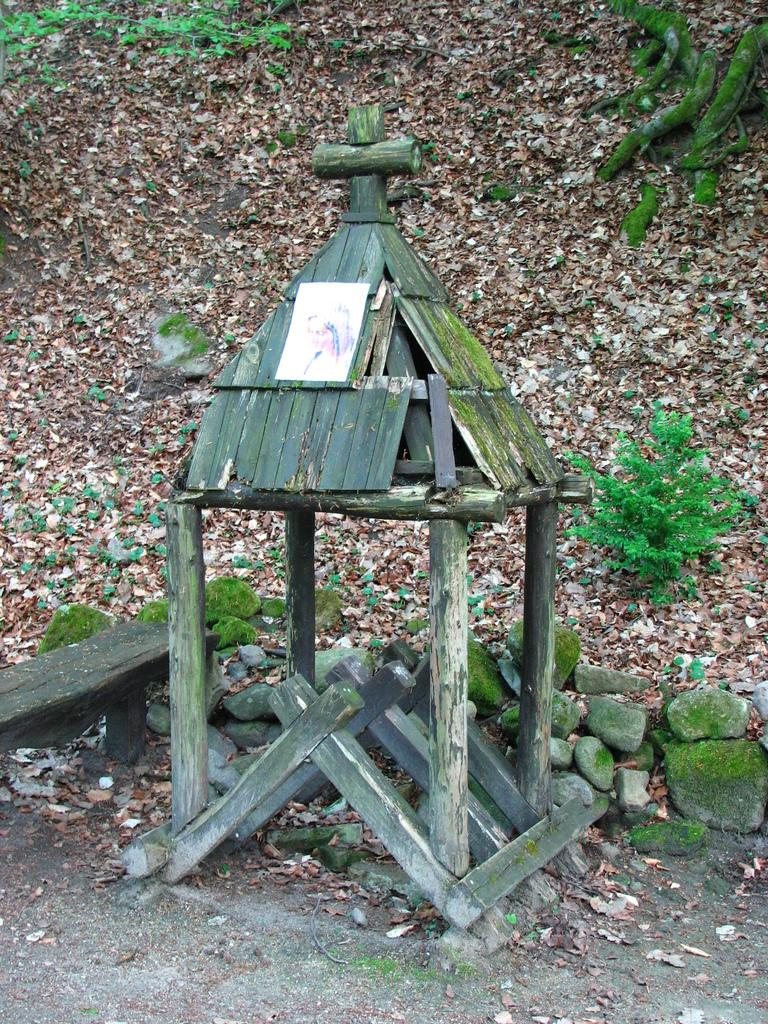What type of structure is visible in the image? There is a small hut in the image. What material is the hut made of? The hut is made up of wood. What natural elements can be seen in the image? There are stones, dry leaves, plants, and grass in the image. What color is the curtain hanging in the hut in the image? There is no curtain present in the image. What is the name of the yak standing next to the hut in the image? There is no yak present in the image. 